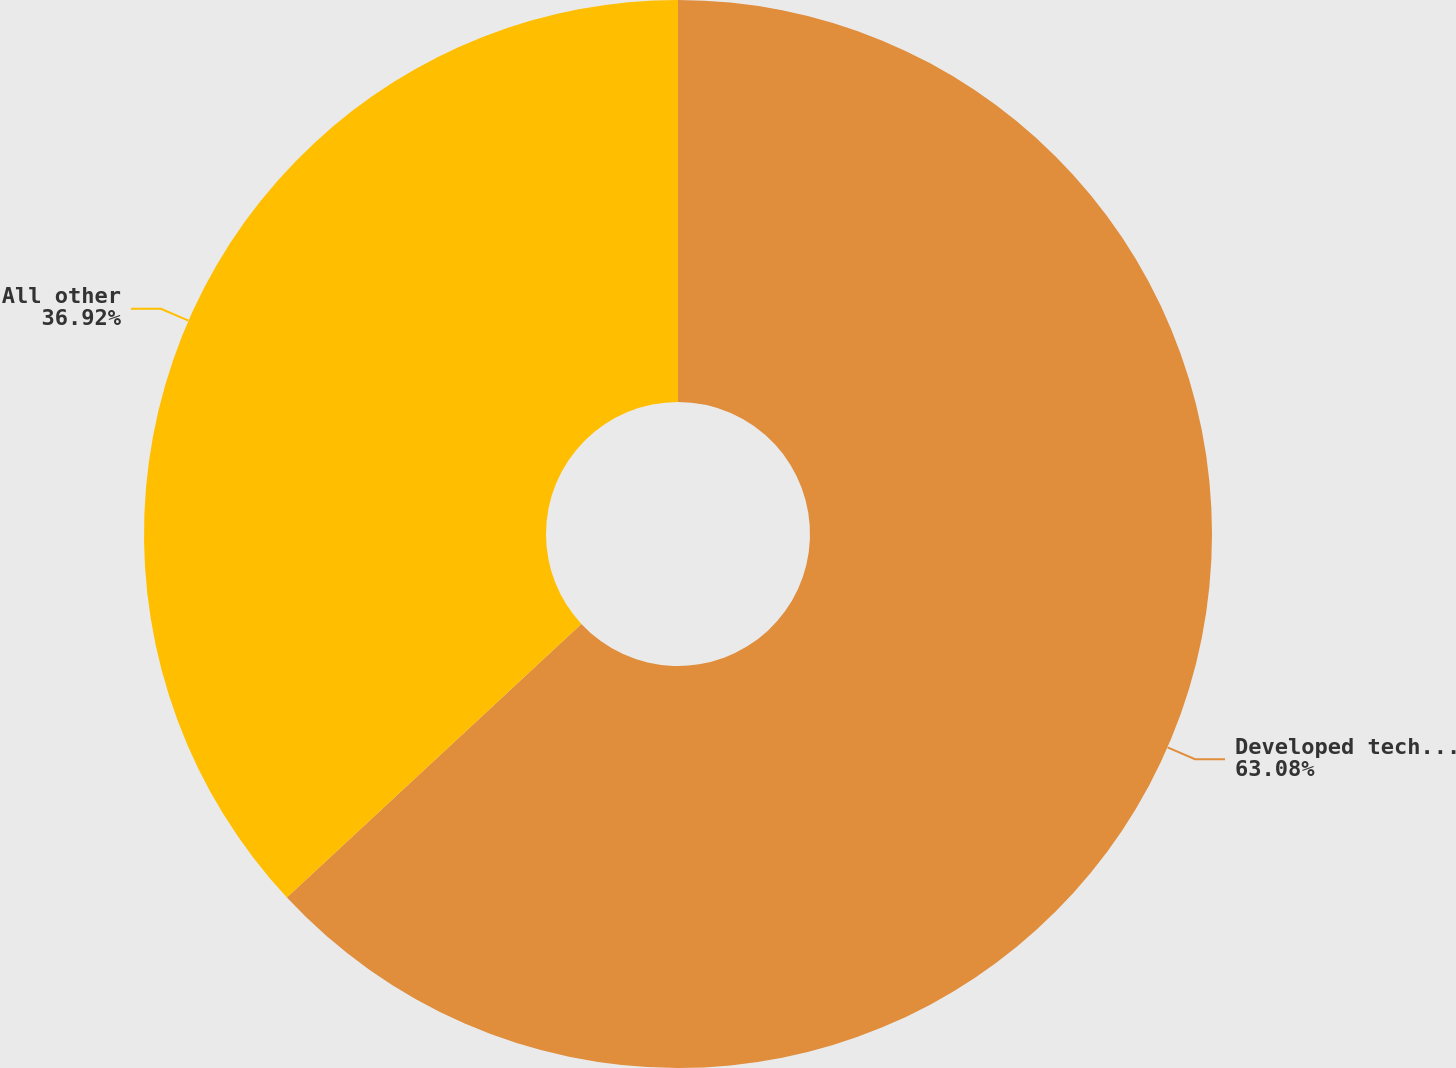Convert chart. <chart><loc_0><loc_0><loc_500><loc_500><pie_chart><fcel>Developed technologies<fcel>All other<nl><fcel>63.08%<fcel>36.92%<nl></chart> 